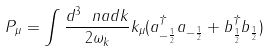Convert formula to latex. <formula><loc_0><loc_0><loc_500><loc_500>P _ { \mu } = \int \frac { d ^ { 3 } \ n a d { k } } { 2 \omega _ { k } } k _ { \mu } ( a ^ { \dagger } _ { - \frac { 1 } { 2 } } a _ { - \frac { 1 } { 2 } } + b ^ { \dagger } _ { \frac { 1 } { 2 } } b _ { \frac { 1 } { 2 } } )</formula> 